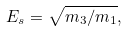<formula> <loc_0><loc_0><loc_500><loc_500>E _ { s } = \sqrt { m _ { 3 } / m _ { 1 } } ,</formula> 